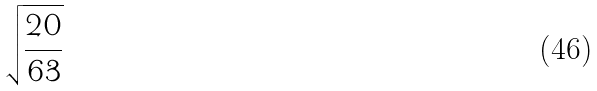<formula> <loc_0><loc_0><loc_500><loc_500>\sqrt { \frac { 2 0 } { 6 3 } }</formula> 